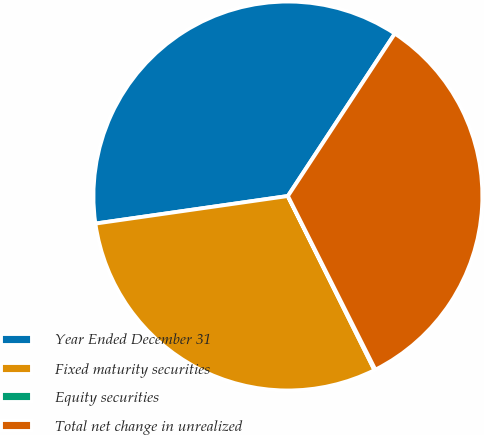Convert chart to OTSL. <chart><loc_0><loc_0><loc_500><loc_500><pie_chart><fcel>Year Ended December 31<fcel>Fixed maturity securities<fcel>Equity securities<fcel>Total net change in unrealized<nl><fcel>36.53%<fcel>30.08%<fcel>0.08%<fcel>33.31%<nl></chart> 